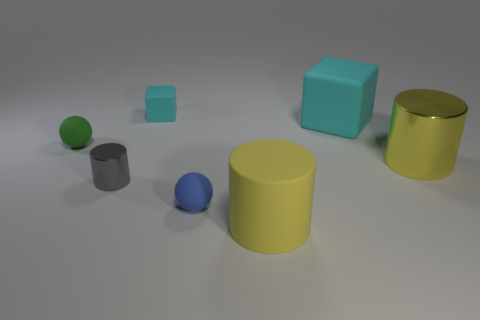Subtract all brown balls. How many yellow cylinders are left? 2 Subtract all metallic cylinders. How many cylinders are left? 1 Add 2 small green cubes. How many objects exist? 9 Subtract all cubes. How many objects are left? 5 Add 6 large yellow metallic cylinders. How many large yellow metallic cylinders exist? 7 Subtract 0 cyan cylinders. How many objects are left? 7 Subtract all large blue rubber cylinders. Subtract all small blue objects. How many objects are left? 6 Add 5 cyan blocks. How many cyan blocks are left? 7 